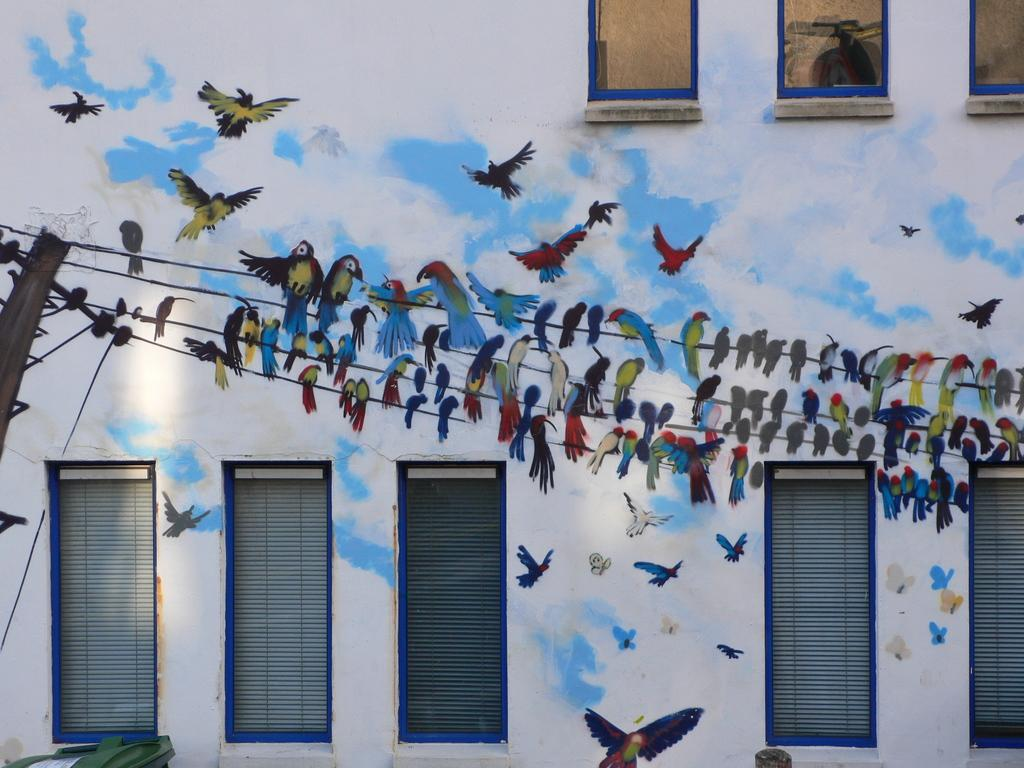What is the main subject of the image? The image depicts a building. What can be seen on the wall of the building? There are paintings of birds on the wall of the building. What is the pole with wires used for? The pole with wires is likely used for electrical or communication purposes. What is located at the bottom of the image? There is a bin at the bottom of the image. Can you describe the unspecified object visible in the image? Unfortunately, the facts provided do not give enough information to describe the unspecified object. How many times does the building crack in the image? There is no indication of the building cracking in the image. What is the name of the downtown area where the building is located? The facts provided do not mention the location of the building, so we cannot determine if it is in a downtown area or provide its name. 